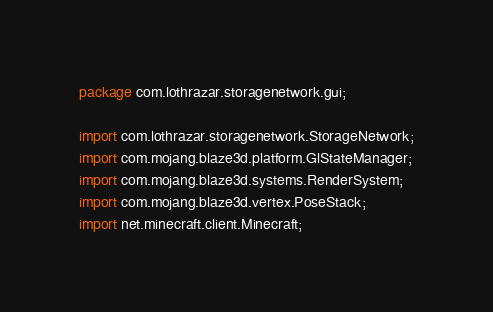Convert code to text. <code><loc_0><loc_0><loc_500><loc_500><_Java_>package com.lothrazar.storagenetwork.gui;

import com.lothrazar.storagenetwork.StorageNetwork;
import com.mojang.blaze3d.platform.GlStateManager;
import com.mojang.blaze3d.systems.RenderSystem;
import com.mojang.blaze3d.vertex.PoseStack;
import net.minecraft.client.Minecraft;</code> 